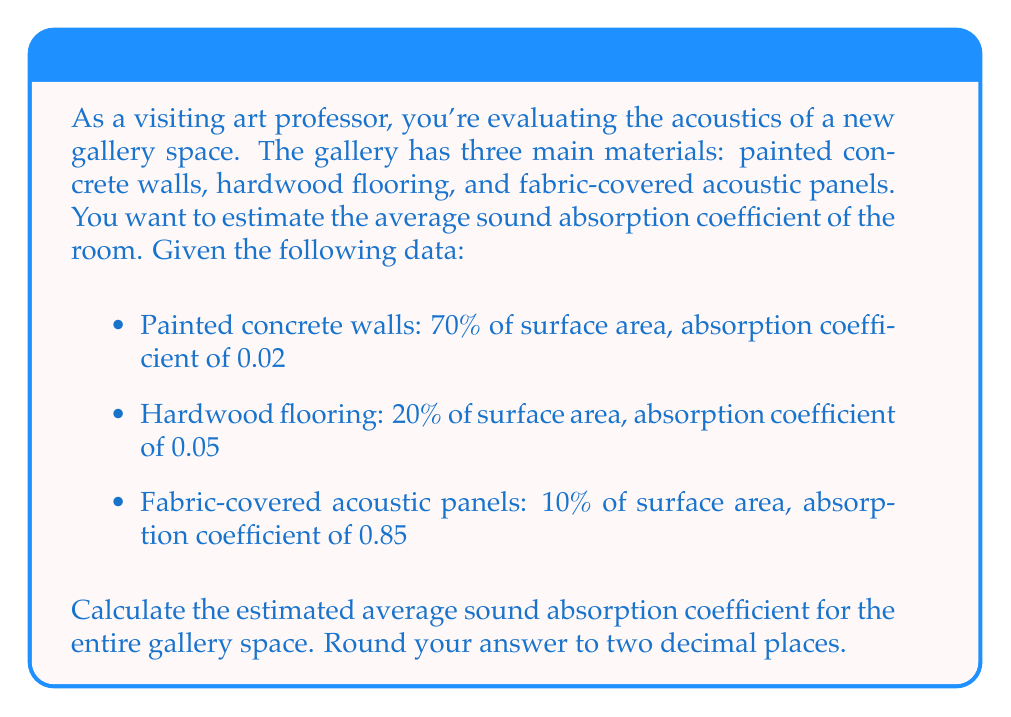Help me with this question. To estimate the average sound absorption coefficient for the gallery, we need to use a weighted average based on the surface area percentages of each material. The formula for this calculation is:

$$\alpha_{avg} = \sum_{i=1}^{n} (S_i \cdot \alpha_i)$$

Where:
$\alpha_{avg}$ is the average absorption coefficient
$S_i$ is the fraction of total surface area for material i
$\alpha_i$ is the absorption coefficient for material i

Let's substitute the given values:

1. Painted concrete walls:
   $S_1 = 0.70$, $\alpha_1 = 0.02$
   
2. Hardwood flooring:
   $S_2 = 0.20$, $\alpha_2 = 0.05$
   
3. Fabric-covered acoustic panels:
   $S_3 = 0.10$, $\alpha_3 = 0.85$

Now, let's calculate:

$$\begin{align}
\alpha_{avg} &= (S_1 \cdot \alpha_1) + (S_2 \cdot \alpha_2) + (S_3 \cdot \alpha_3) \\
&= (0.70 \cdot 0.02) + (0.20 \cdot 0.05) + (0.10 \cdot 0.85) \\
&= 0.014 + 0.010 + 0.085 \\
&= 0.109
\end{align}$$

Rounding to two decimal places, we get 0.11.
Answer: The estimated average sound absorption coefficient for the entire gallery space is 0.11. 